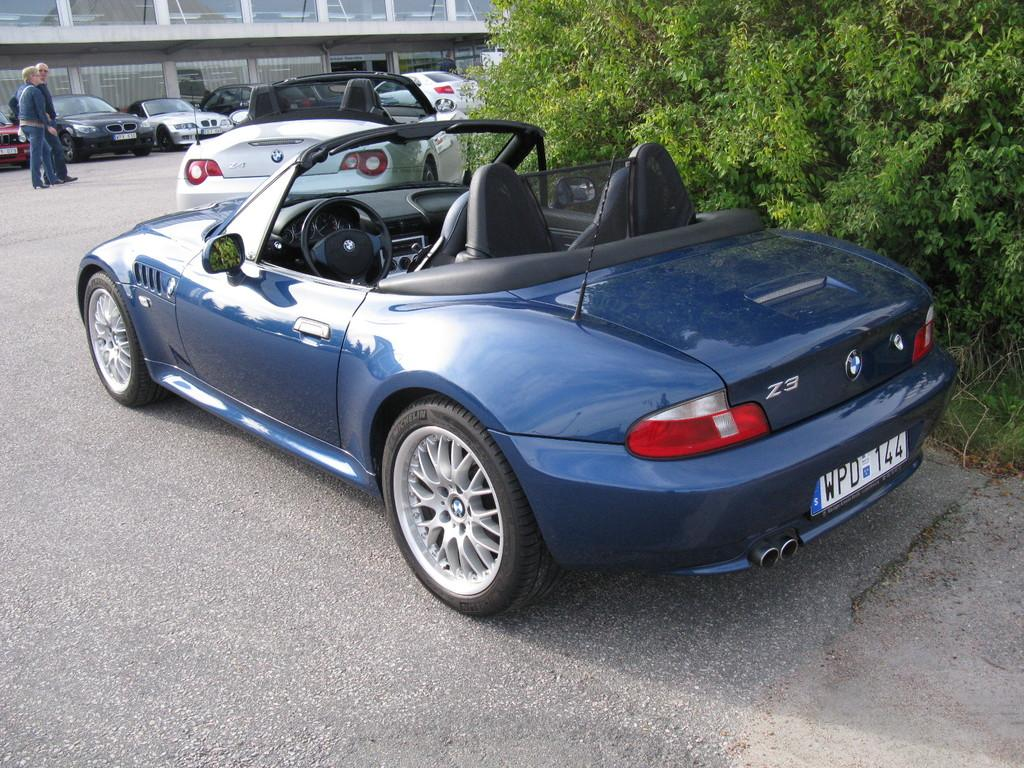What types of objects can be seen in the image? There are vehicles and people in the image. What is the setting of the image? There is a road, plants, and grass in the image, suggesting an outdoor setting. Can you describe the building in the image? There is a building with glass doors in the image. What type of brass instrument is being played by the people in the image? There is no brass instrument or any indication of music being played in the image. 